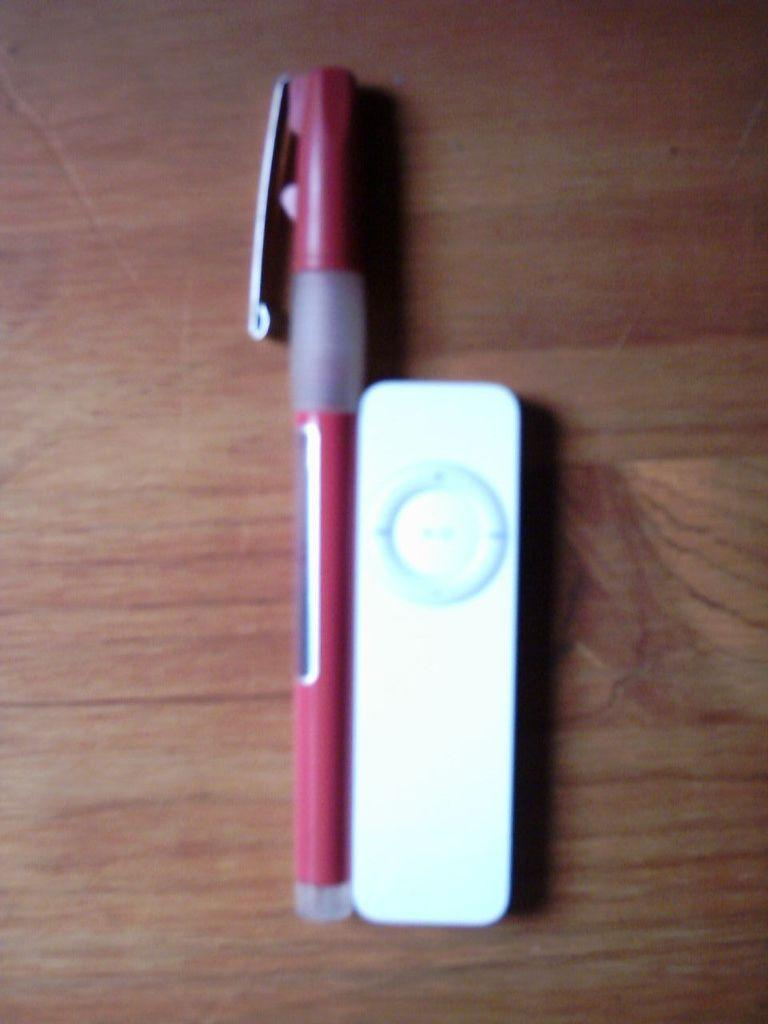Where was the image taken? The image is taken indoors. What piece of furniture is present in the image? There is a table in the image. What objects can be seen on the table? There is a pen and a remote on the table. How many eggs are on the table in the image? There are no eggs present on the table in the image. What type of corn is growing in the image? There is no corn present in the image. 